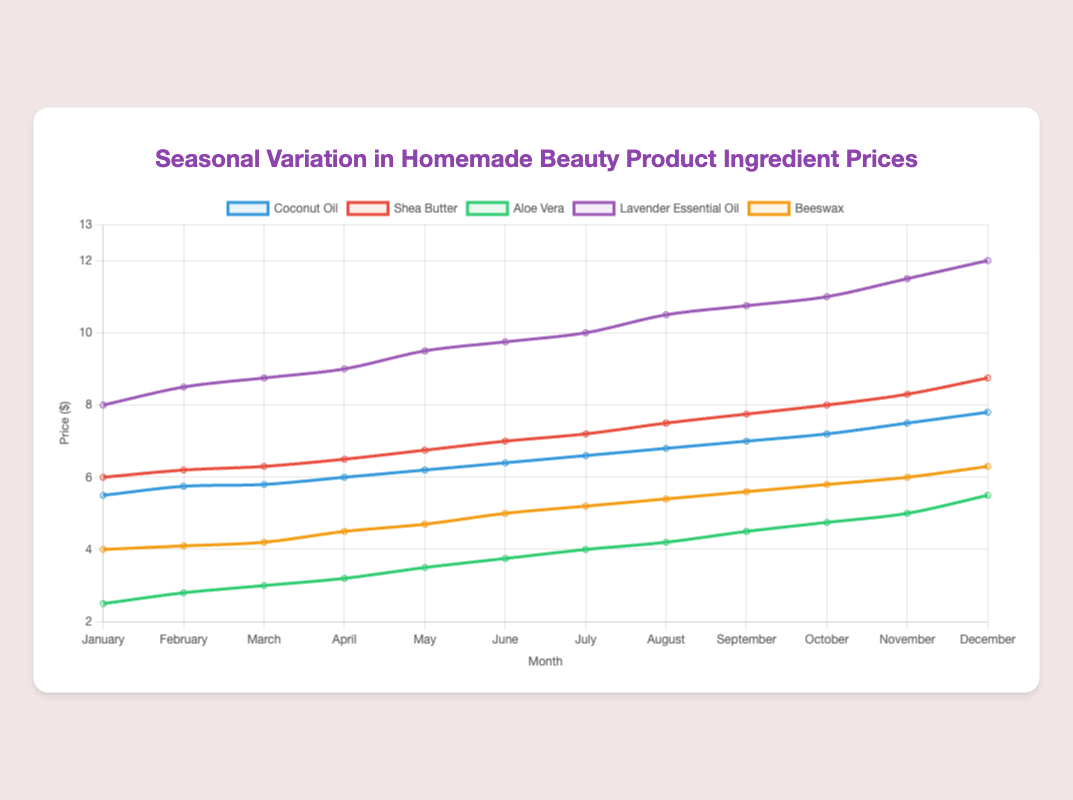What is the price of Coconut Oil in June? The data shows the price of Coconut Oil for each month. In June, the price is listed.
Answer: 6.40 Which ingredient has the highest price in December? The data indicates the prices for each ingredient across all months. In December, compare the prices to find the highest one.
Answer: Lavender Essential Oil How does the price of Shea Butter change from January to December? To find the price change, subtract the January price of Shea Butter from the December price. Shea Butter is 6.00 in January and 8.75 in December. The change is 8.75 - 6.00.
Answer: 2.75 Which ingredient shows the least variation in price throughout the year? Analyze the price range (difference between highest and lowest prices) of each ingredient. Compare the variations to determine the smallest one. Aloe Vera ranges from 2.50 to 5.50, a 3.00 range.
Answer: Aloe Vera In which month did Beeswax experience the highest increase in price compared to the previous month? Compare the monthly price increases for Beeswax. The largest increase is the difference between consecutive months. The highest jump is from October to November, 5.80 to 6.00.
Answer: November What is the average price of Lavender Essential Oil over the year? Sum the prices of Lavender Essential Oil for each month and divide by 12. Prices are (8.00 + 8.50 + 8.75 + 9.00 + 9.50 + 9.75 + 10.00 + 10.50 + 10.75 + 11.00 + 11.50 + 12.00). The sum is 119.25, so the average is 119.25/12.
Answer: 9.94 Is the price of Aloe Vera higher in July or in January? Compare the prices of Aloe Vera in July and January. January is 2.50 and July is 4.00.
Answer: July What's the median price of Beeswax over the 12 months? Arrange the prices of Beeswax in ascending order and find the middle value. Prices are (4.00, 4.10, 4.20, 4.50, 4.70, 5.00, 5.20, 5.40, 5.60, 5.80, 6.00, 6.30). The middle values are 5.00 and 5.20, so median is the average of these two.
Answer: 5.10 By how much did the price of Coconut Oil increase from February to March? Subtract the February price of Coconut Oil from the March price. February is 5.75 and March is 5.80. The increase is 5.80 - 5.75.
Answer: 0.05 Which ingredient's price shows a consistent upward trend throughout the year? Examine each ingredient's price month by month to determine if it's consistently increasing. All ingredients show an increase.
Answer: All ingredients show this trend 